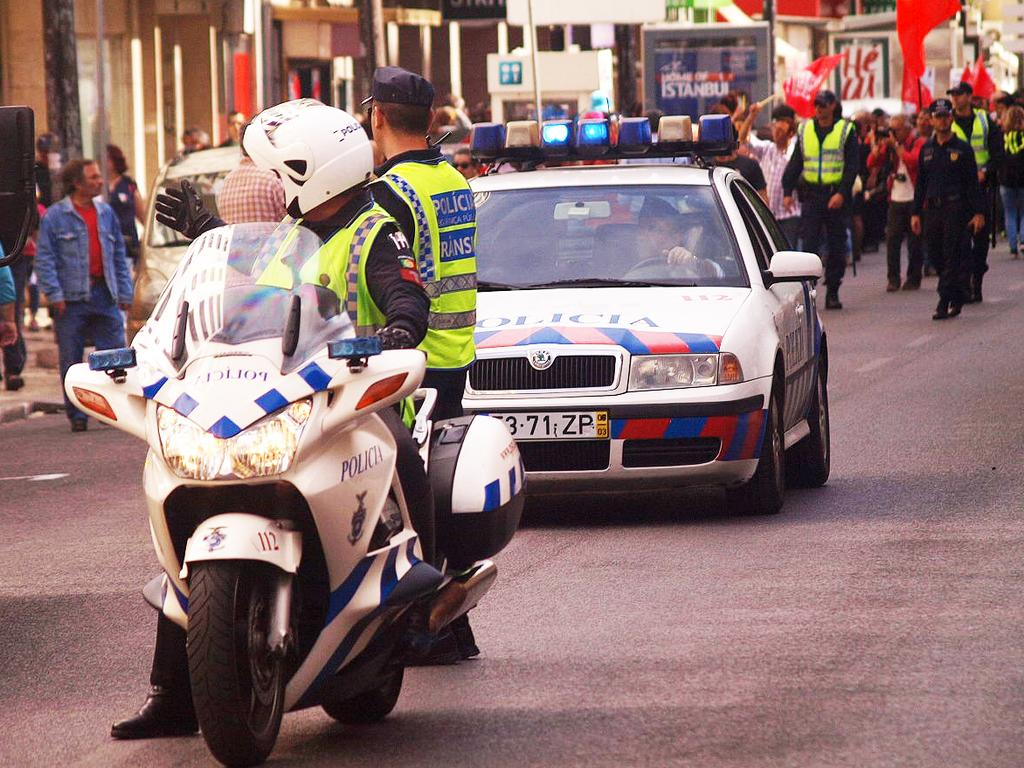What is the police officer doing in the image? The police officer is sitting on a bike. What vehicle is visible behind the officer? There is a police car behind the officer. Can you describe the scene in the background? There is a group of people in the background. What type of wilderness can be seen in the background of the image? There is no wilderness present in the image; it features a police officer, a police car, and a group of people. Can you identify the actor playing the police officer in the image? There is no actor playing the police officer in the image; it is a real police officer. 